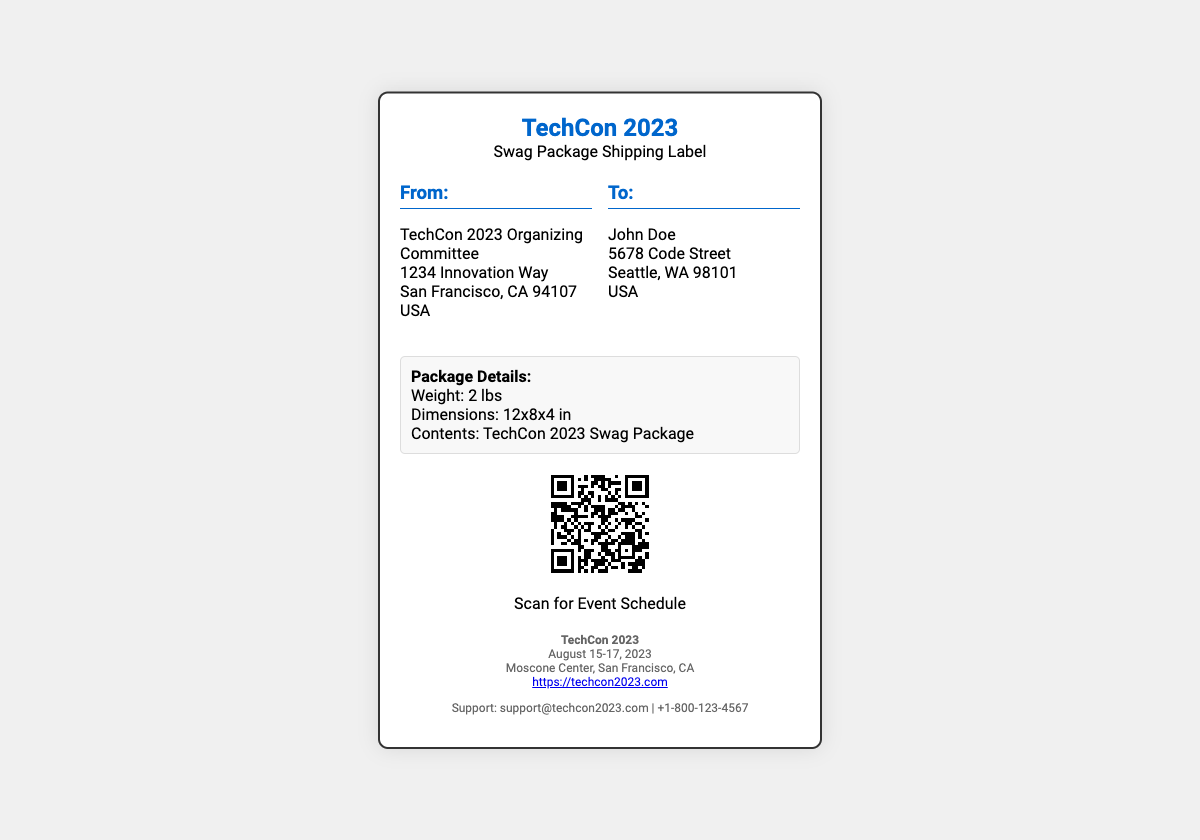What is the weight of the package? The weight of the package is listed in the package details section, which states it is 2 lbs.
Answer: 2 lbs Who is the recipient of the package? The recipient's name is stated in the "To" section of the address, which shows "John Doe".
Answer: John Doe What are the dimensions of the package? The dimensions can be found in the package details, showing "12x8x4 in".
Answer: 12x8x4 in What is the event date for TechCon 2023? The event date is indicated in the conference details, which lists "August 15-17, 2023".
Answer: August 15-17, 2023 Where is TechCon 2023 being held? The location is given in the conference details section, stating "Moscone Center, San Francisco, CA".
Answer: Moscone Center, San Francisco, CA What is the URL for the event schedule in the QR code? The URL encoded in the QR code is referenced right below it, which is "https://techcon2023.com/schedule".
Answer: https://techcon2023.com/schedule What type of package is being shipped? The type of package is specified in the package details, stating "TechCon 2023 Swag Package".
Answer: TechCon 2023 Swag Package What is the support email for the conference? The support email is located in the support section, which lists "support@techcon2023.com".
Answer: support@techcon2023.com 